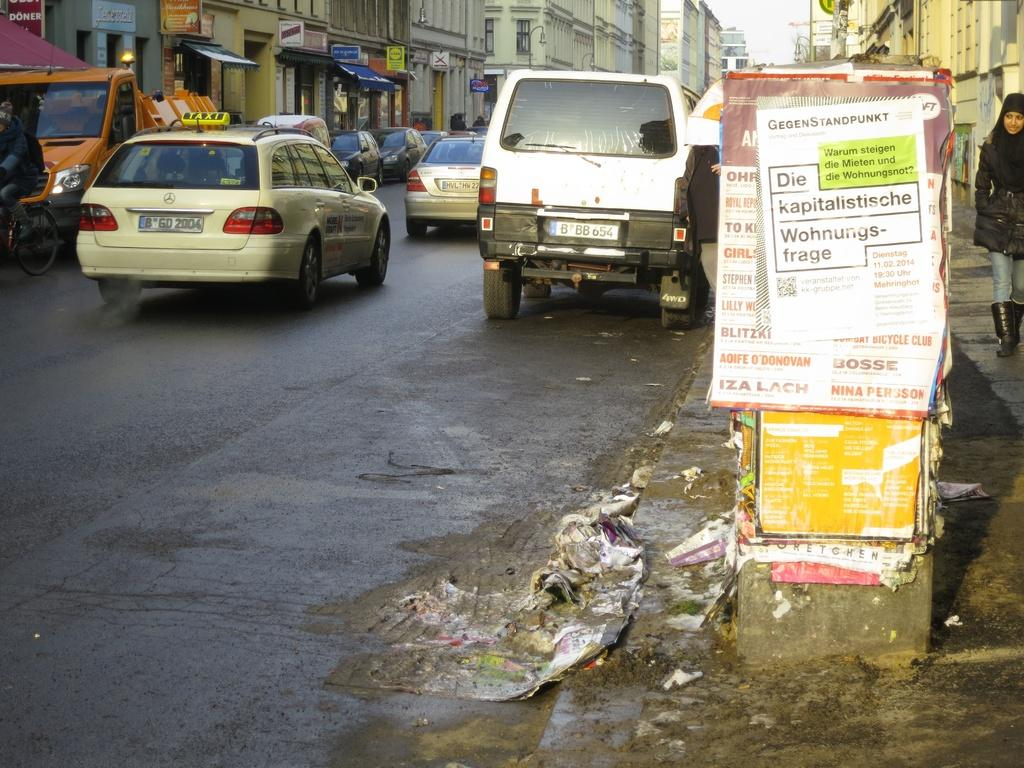<image>
Relay a brief, clear account of the picture shown. Several cars are driving past a sign that says Die kapitalistische. 